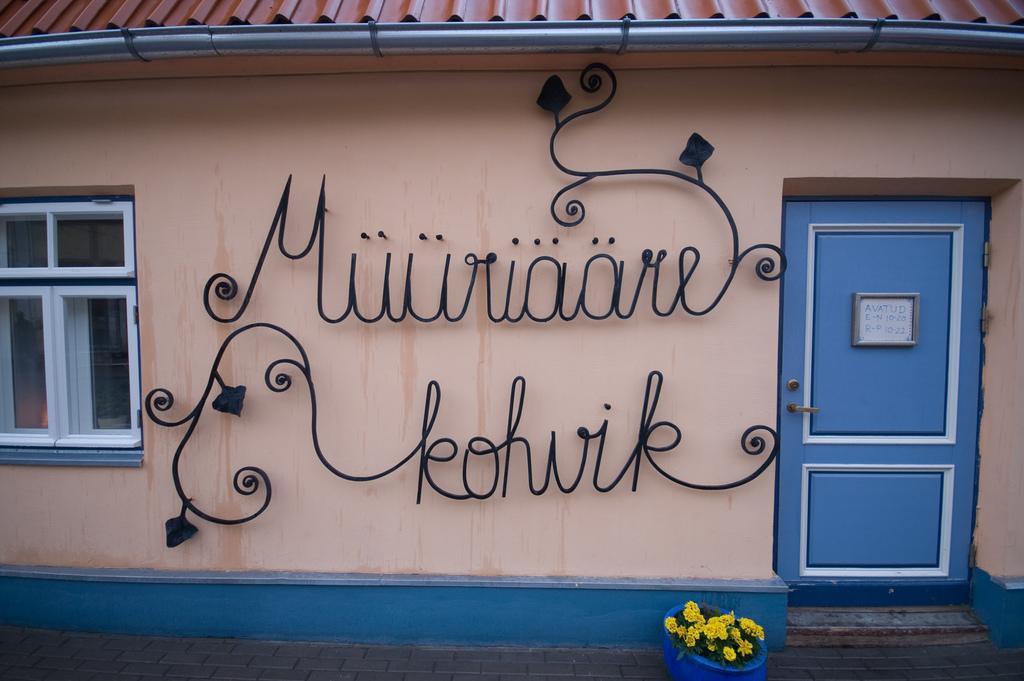Could you give a brief overview of what you see in this image? In this image there is a plant with flowers in a pot , a building with name boards , door, window. 